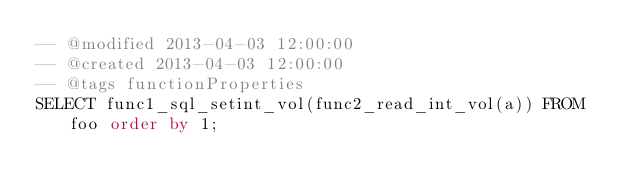<code> <loc_0><loc_0><loc_500><loc_500><_SQL_>-- @modified 2013-04-03 12:00:00
-- @created 2013-04-03 12:00:00
-- @tags functionProperties 
SELECT func1_sql_setint_vol(func2_read_int_vol(a)) FROM foo order by 1; 
</code> 